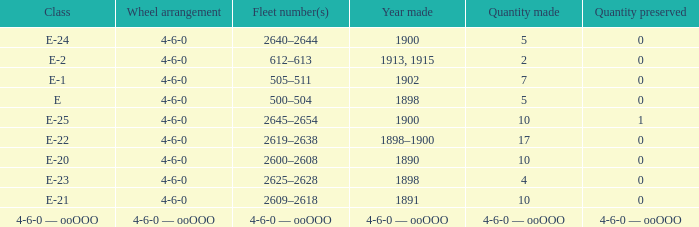Give me the full table as a dictionary. {'header': ['Class', 'Wheel arrangement', 'Fleet number(s)', 'Year made', 'Quantity made', 'Quantity preserved'], 'rows': [['E-24', '4-6-0', '2640–2644', '1900', '5', '0'], ['E-2', '4-6-0', '612–613', '1913, 1915', '2', '0'], ['E-1', '4-6-0', '505–511', '1902', '7', '0'], ['E', '4-6-0', '500–504', '1898', '5', '0'], ['E-25', '4-6-0', '2645–2654', '1900', '10', '1'], ['E-22', '4-6-0', '2619–2638', '1898–1900', '17', '0'], ['E-20', '4-6-0', '2600–2608', '1890', '10', '0'], ['E-23', '4-6-0', '2625–2628', '1898', '4', '0'], ['E-21', '4-6-0', '2609–2618', '1891', '10', '0'], ['4-6-0 — ooOOO', '4-6-0 — ooOOO', '4-6-0 — ooOOO', '4-6-0 — ooOOO', '4-6-0 — ooOOO', '4-6-0 — ooOOO']]} What is the quantity preserved of the e-1 class? 0.0. 